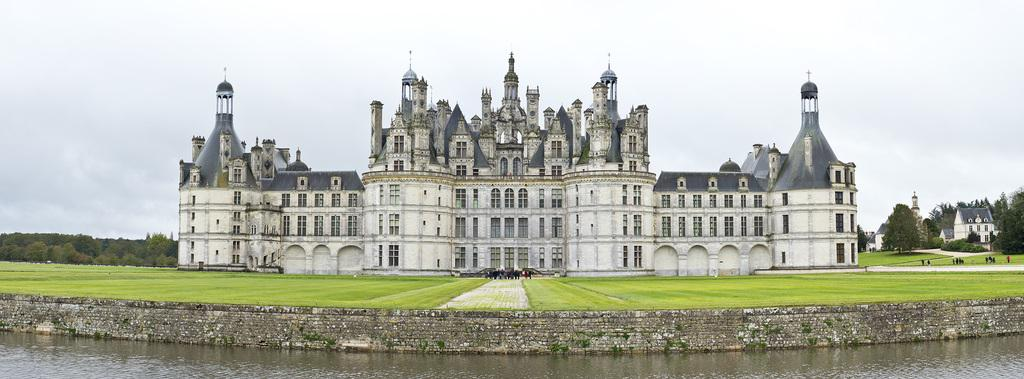What is the main structure in the center of the image? There is a palace in the center of the image. What can be seen in the background of the image? There are trees in the background of the image. What is visible at the bottom of the image? There is water visible at the bottom of the image. What type of company is operating the boats in the image? There are no boats present in the image, so it is not possible to determine the type of company operating them. 